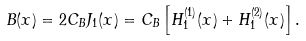Convert formula to latex. <formula><loc_0><loc_0><loc_500><loc_500>B ( x ) = 2 C _ { B } J _ { 1 } ( x ) = C _ { B } \left [ H _ { 1 } ^ { ( 1 ) } ( x ) + H _ { 1 } ^ { ( 2 ) } ( x ) \right ] .</formula> 